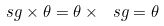<formula> <loc_0><loc_0><loc_500><loc_500>\ s g \times \theta = \theta \times \ s g = \theta</formula> 